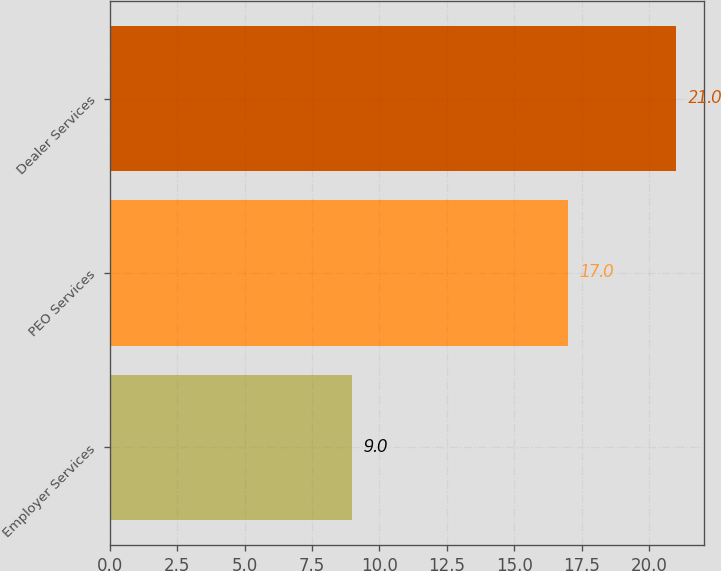Convert chart to OTSL. <chart><loc_0><loc_0><loc_500><loc_500><bar_chart><fcel>Employer Services<fcel>PEO Services<fcel>Dealer Services<nl><fcel>9<fcel>17<fcel>21<nl></chart> 